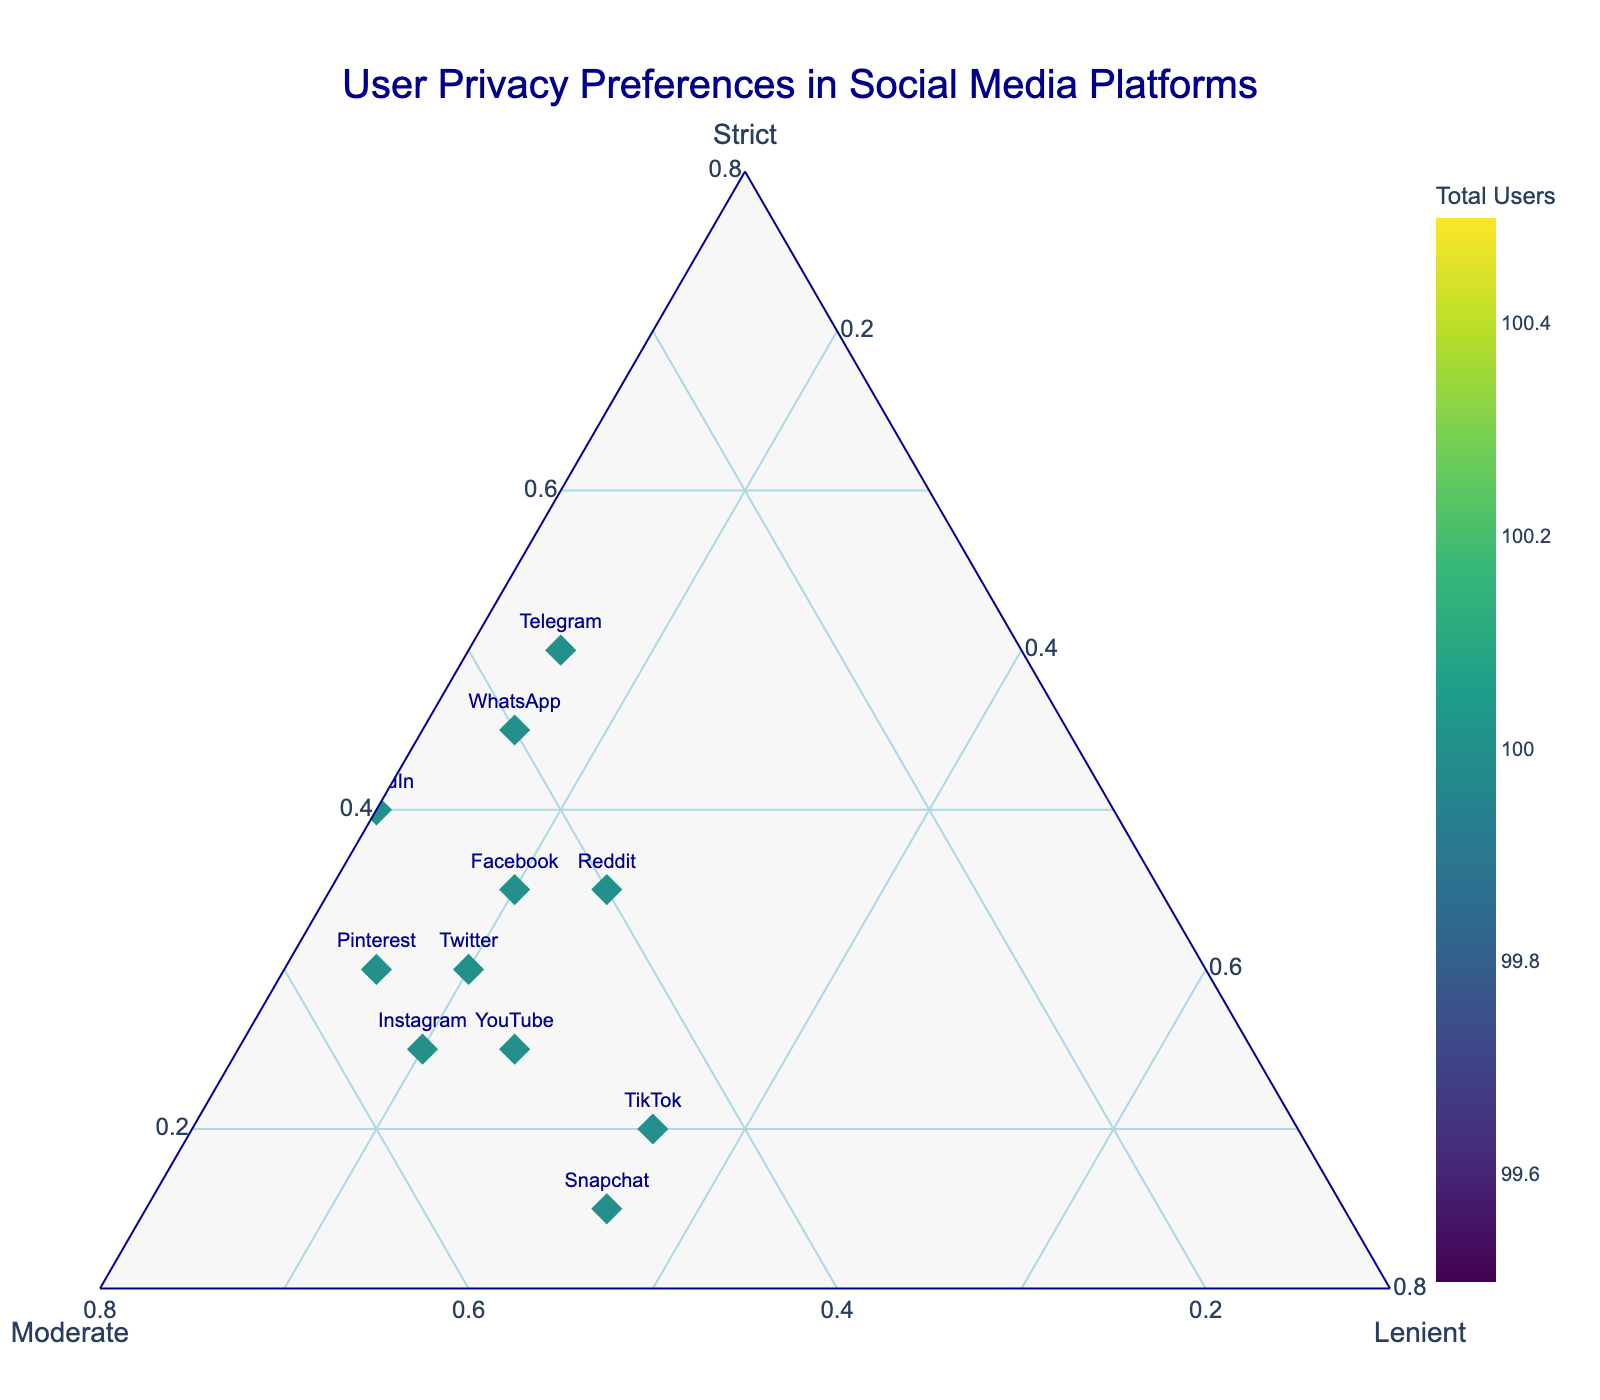What is the title of the ternary plot? The title is located at the top of the figure and describes the overall subject of the plot.
Answer: User Privacy Preferences in Social Media Platforms Which social media platform shows the highest preference for strict privacy settings? To find the platform with the highest preference for strict privacy settings, locate the marker closest to the "Strict" axis.
Answer: Signal Which platform is favored for lenient privacy settings as the highest preference? Identify the marker closest to the "Lenient" axis.
Answer: TikTok How does Reddit's preference distribution compare to YouTube's? Assess the relative positions of the markers for Reddit and YouTube for each privacy setting axis (Strict, Moderate, Lenient).
Answer: Reddit has higher strict preferences, similar moderate preferences, and slightly lower lenient preferences compared to YouTube Which platform has a higher total user count, Telegram or WhatsApp? The total user count is indicated by the color bar. Compare the colors of the markers for Telegram and WhatsApp.
Answer: WhatsApp What is the combination of privacy preferences for LinkedIn? Look at the position of the LinkedIn marker relative to the "Strict," "Moderate," and "Lenient" axes to determine the combination.
Answer: 40% Strict, 50% Moderate, 10% Lenient Is there a platform with equal preference for strict and lenient settings? Check if any marker lies equidistant from the "Strict" and "Lenient" axes.
Answer: No How does the distribution of privacy preferences on Snapchat compare to Instagram? Compare their respective positions on each of the "Strict," "Moderate," and "Lenient" axes.
Answer: Snapchat has lower strict preferences, similar moderate preferences, and higher lenient preferences compared to Instagram Which platform has the lowest strict preference among the listed platforms? Locate the marker farthest from the "Strict" axis.
Answer: Snapchat 